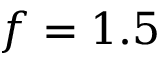Convert formula to latex. <formula><loc_0><loc_0><loc_500><loc_500>f = 1 . 5</formula> 